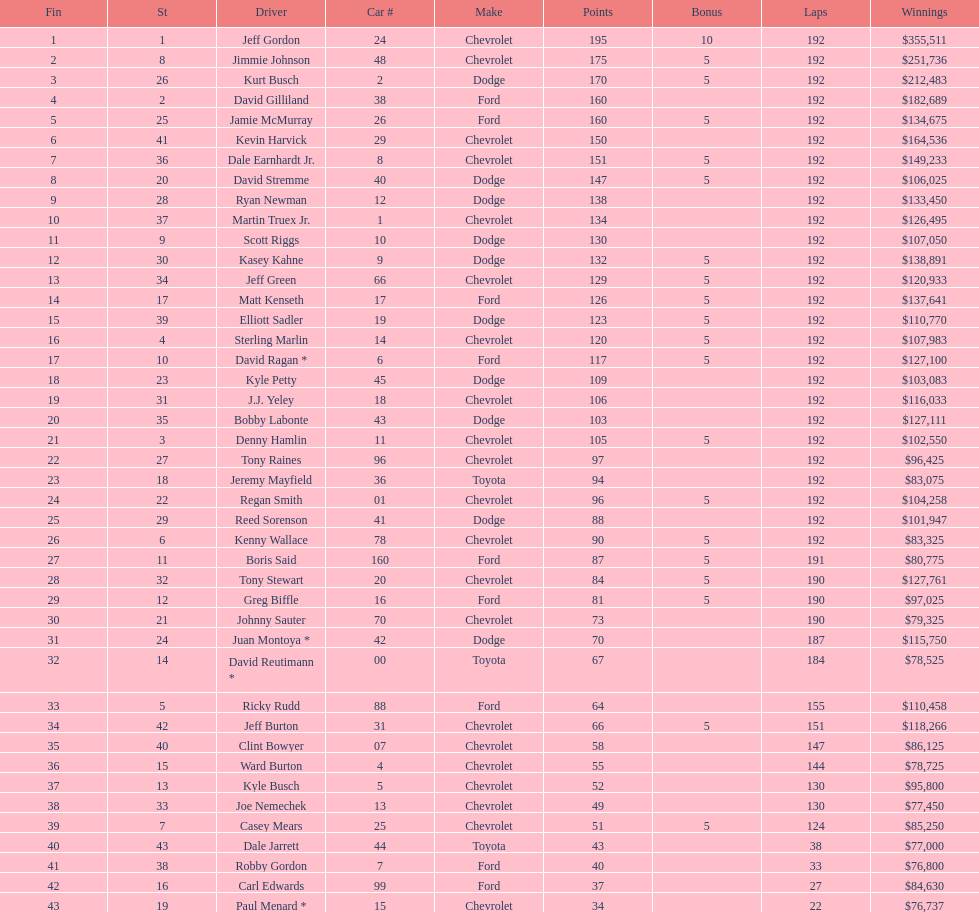What was the make of both jeff gordon's and jimmie johnson's race car? Chevrolet. 